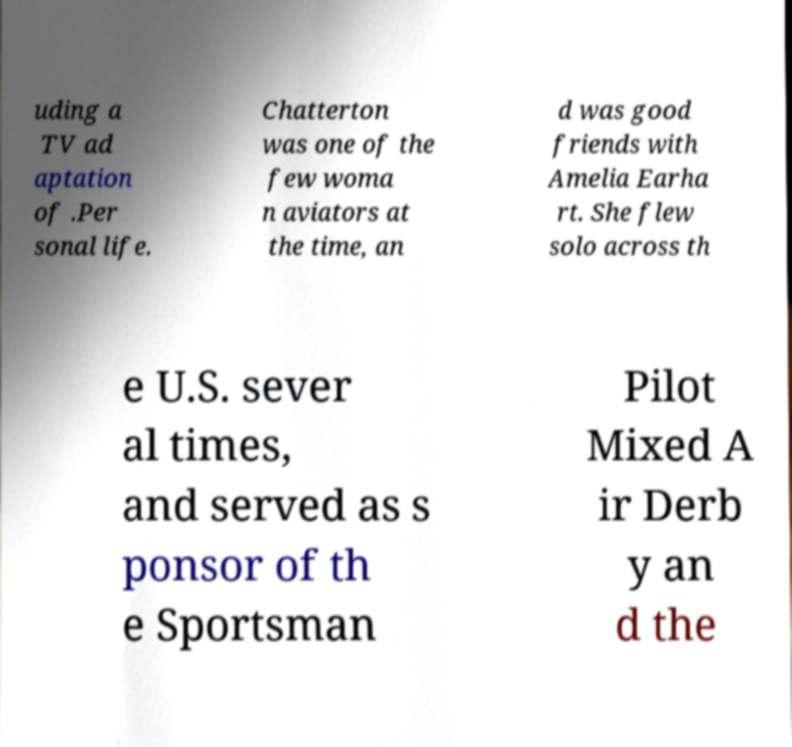Can you accurately transcribe the text from the provided image for me? uding a TV ad aptation of .Per sonal life. Chatterton was one of the few woma n aviators at the time, an d was good friends with Amelia Earha rt. She flew solo across th e U.S. sever al times, and served as s ponsor of th e Sportsman Pilot Mixed A ir Derb y an d the 